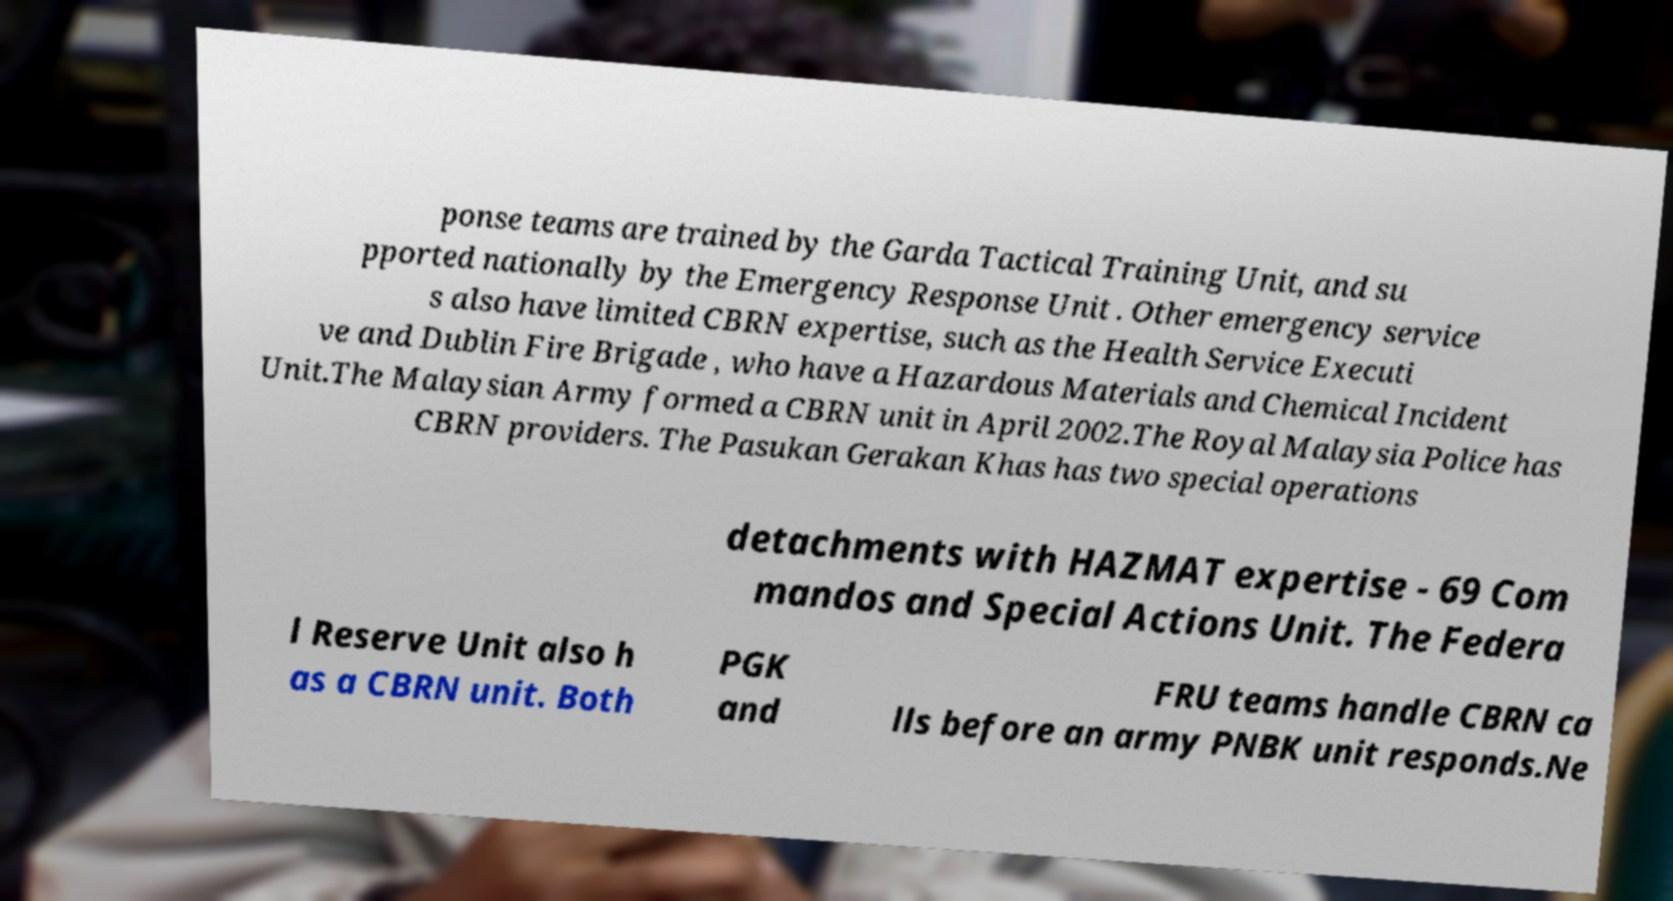Please read and relay the text visible in this image. What does it say? ponse teams are trained by the Garda Tactical Training Unit, and su pported nationally by the Emergency Response Unit . Other emergency service s also have limited CBRN expertise, such as the Health Service Executi ve and Dublin Fire Brigade , who have a Hazardous Materials and Chemical Incident Unit.The Malaysian Army formed a CBRN unit in April 2002.The Royal Malaysia Police has CBRN providers. The Pasukan Gerakan Khas has two special operations detachments with HAZMAT expertise - 69 Com mandos and Special Actions Unit. The Federa l Reserve Unit also h as a CBRN unit. Both PGK and FRU teams handle CBRN ca lls before an army PNBK unit responds.Ne 